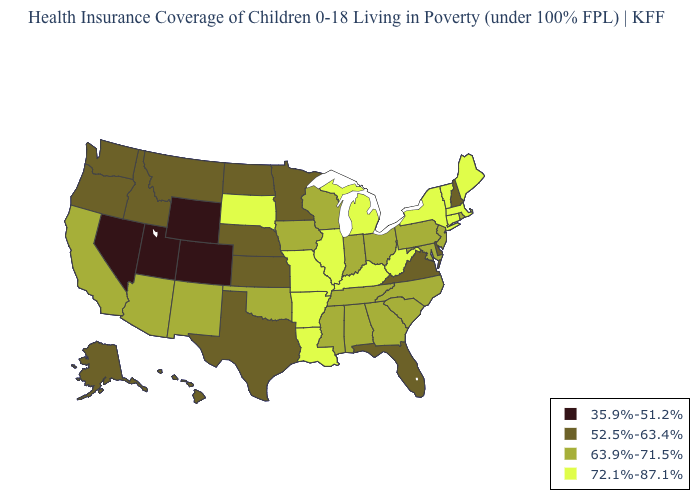What is the value of Iowa?
Concise answer only. 63.9%-71.5%. What is the value of California?
Write a very short answer. 63.9%-71.5%. How many symbols are there in the legend?
Be succinct. 4. Name the states that have a value in the range 63.9%-71.5%?
Write a very short answer. Alabama, Arizona, California, Georgia, Indiana, Iowa, Maryland, Mississippi, New Jersey, New Mexico, North Carolina, Ohio, Oklahoma, Pennsylvania, Rhode Island, South Carolina, Tennessee, Wisconsin. Name the states that have a value in the range 63.9%-71.5%?
Write a very short answer. Alabama, Arizona, California, Georgia, Indiana, Iowa, Maryland, Mississippi, New Jersey, New Mexico, North Carolina, Ohio, Oklahoma, Pennsylvania, Rhode Island, South Carolina, Tennessee, Wisconsin. Does Rhode Island have the highest value in the USA?
Answer briefly. No. Which states have the highest value in the USA?
Answer briefly. Arkansas, Connecticut, Illinois, Kentucky, Louisiana, Maine, Massachusetts, Michigan, Missouri, New York, South Dakota, Vermont, West Virginia. Name the states that have a value in the range 52.5%-63.4%?
Give a very brief answer. Alaska, Delaware, Florida, Hawaii, Idaho, Kansas, Minnesota, Montana, Nebraska, New Hampshire, North Dakota, Oregon, Texas, Virginia, Washington. What is the highest value in states that border Missouri?
Answer briefly. 72.1%-87.1%. Which states have the lowest value in the USA?
Quick response, please. Colorado, Nevada, Utah, Wyoming. What is the highest value in the South ?
Answer briefly. 72.1%-87.1%. What is the value of Delaware?
Concise answer only. 52.5%-63.4%. What is the lowest value in the South?
Answer briefly. 52.5%-63.4%. Among the states that border Kansas , which have the highest value?
Answer briefly. Missouri. Which states have the lowest value in the South?
Keep it brief. Delaware, Florida, Texas, Virginia. 